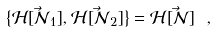Convert formula to latex. <formula><loc_0><loc_0><loc_500><loc_500>\left \{ { \mathcal { H } } [ \vec { \mathcal { N } } _ { 1 } ] , { \mathcal { H } } [ \vec { \mathcal { N } } _ { 2 } ] \right \} = { \mathcal { H } } [ \vec { \mathcal { N } } ] \ ,</formula> 